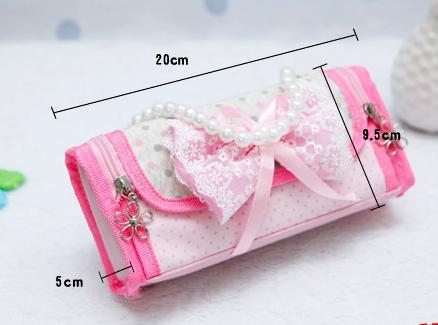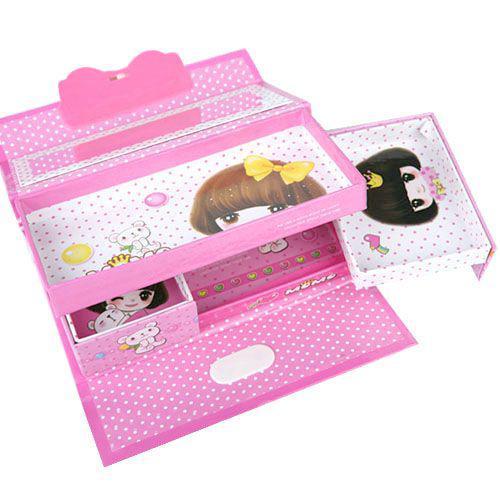The first image is the image on the left, the second image is the image on the right. Evaluate the accuracy of this statement regarding the images: "The left image shows exactly one pencil case.". Is it true? Answer yes or no. Yes. 